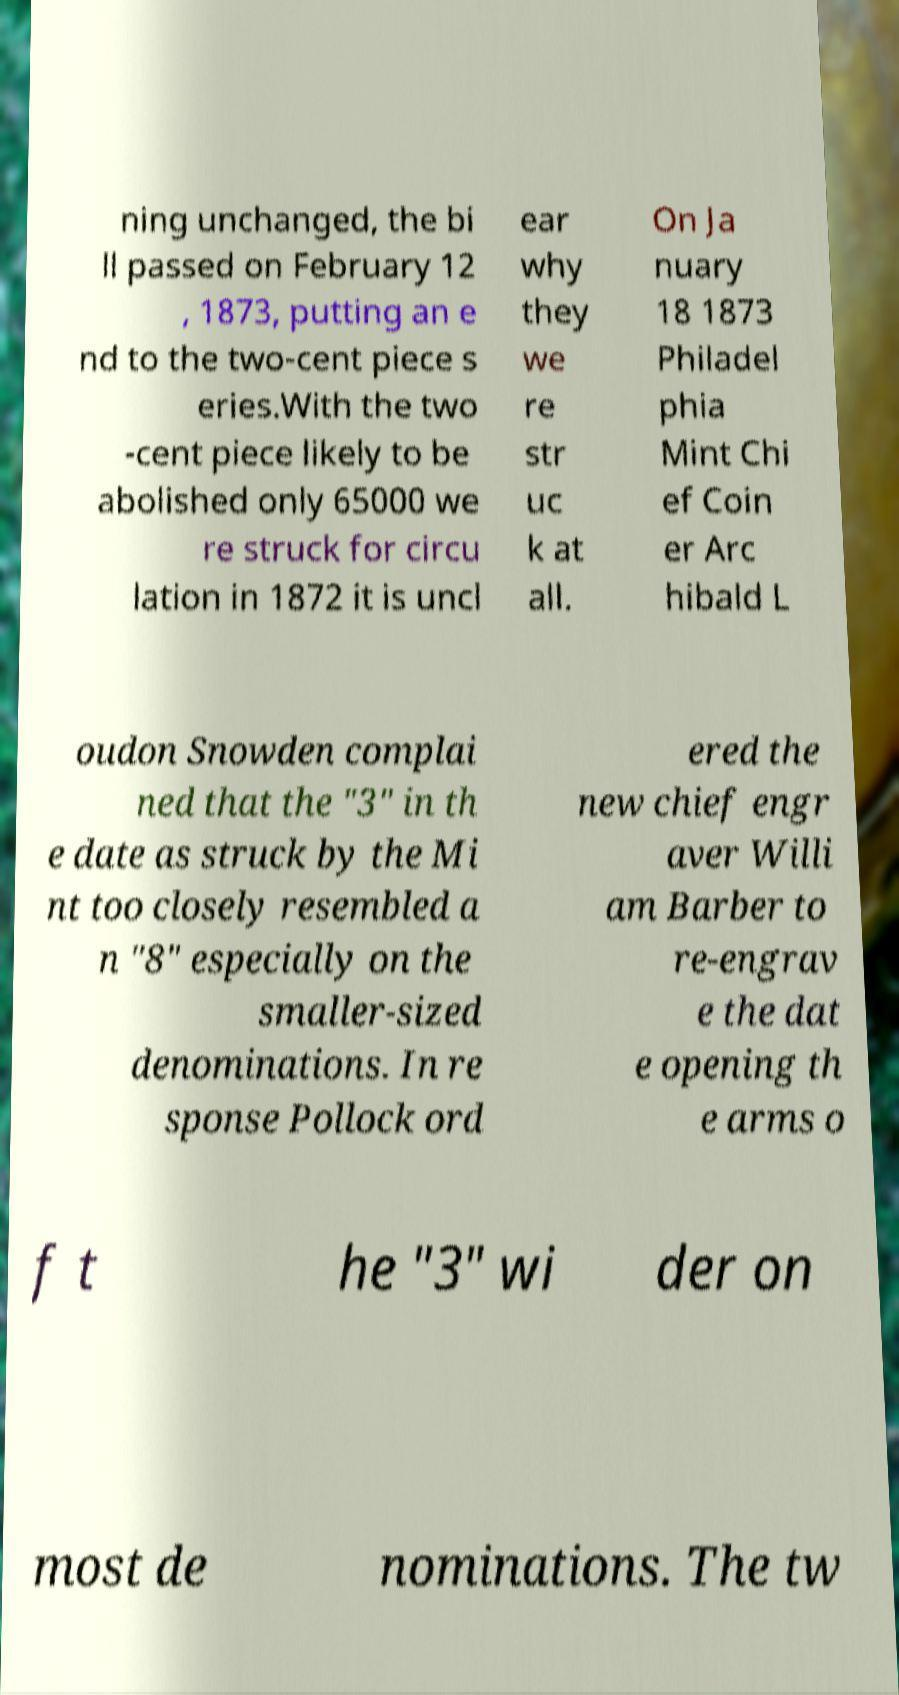Please identify and transcribe the text found in this image. ning unchanged, the bi ll passed on February 12 , 1873, putting an e nd to the two-cent piece s eries.With the two -cent piece likely to be abolished only 65000 we re struck for circu lation in 1872 it is uncl ear why they we re str uc k at all. On Ja nuary 18 1873 Philadel phia Mint Chi ef Coin er Arc hibald L oudon Snowden complai ned that the "3" in th e date as struck by the Mi nt too closely resembled a n "8" especially on the smaller-sized denominations. In re sponse Pollock ord ered the new chief engr aver Willi am Barber to re-engrav e the dat e opening th e arms o f t he "3" wi der on most de nominations. The tw 